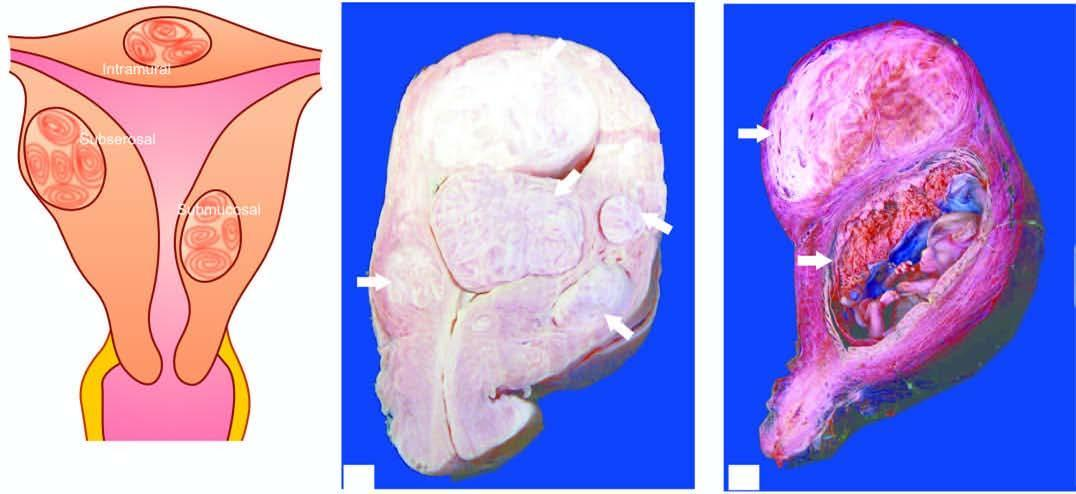how does the opened up uterine cavity show an intrauterine gestation sac?
Answer the question using a single word or phrase. With placenta having grey-white whorled pattern 